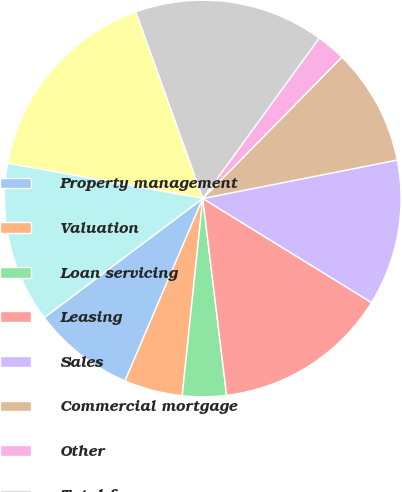<chart> <loc_0><loc_0><loc_500><loc_500><pie_chart><fcel>Property management<fcel>Valuation<fcel>Loan servicing<fcel>Leasing<fcel>Sales<fcel>Commercial mortgage<fcel>Other<fcel>Total fee revenue<fcel>Pass through costs also<fcel>Operating administrative and<nl><fcel>8.33%<fcel>4.76%<fcel>3.57%<fcel>14.29%<fcel>11.9%<fcel>9.52%<fcel>2.38%<fcel>15.48%<fcel>16.67%<fcel>13.1%<nl></chart> 